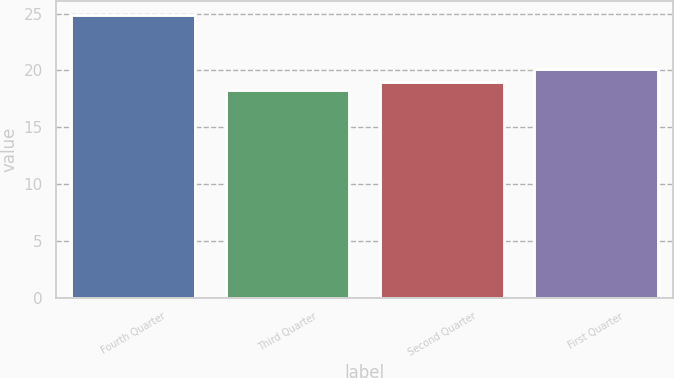Convert chart to OTSL. <chart><loc_0><loc_0><loc_500><loc_500><bar_chart><fcel>Fourth Quarter<fcel>Third Quarter<fcel>Second Quarter<fcel>First Quarter<nl><fcel>24.84<fcel>18.3<fcel>18.95<fcel>20.17<nl></chart> 